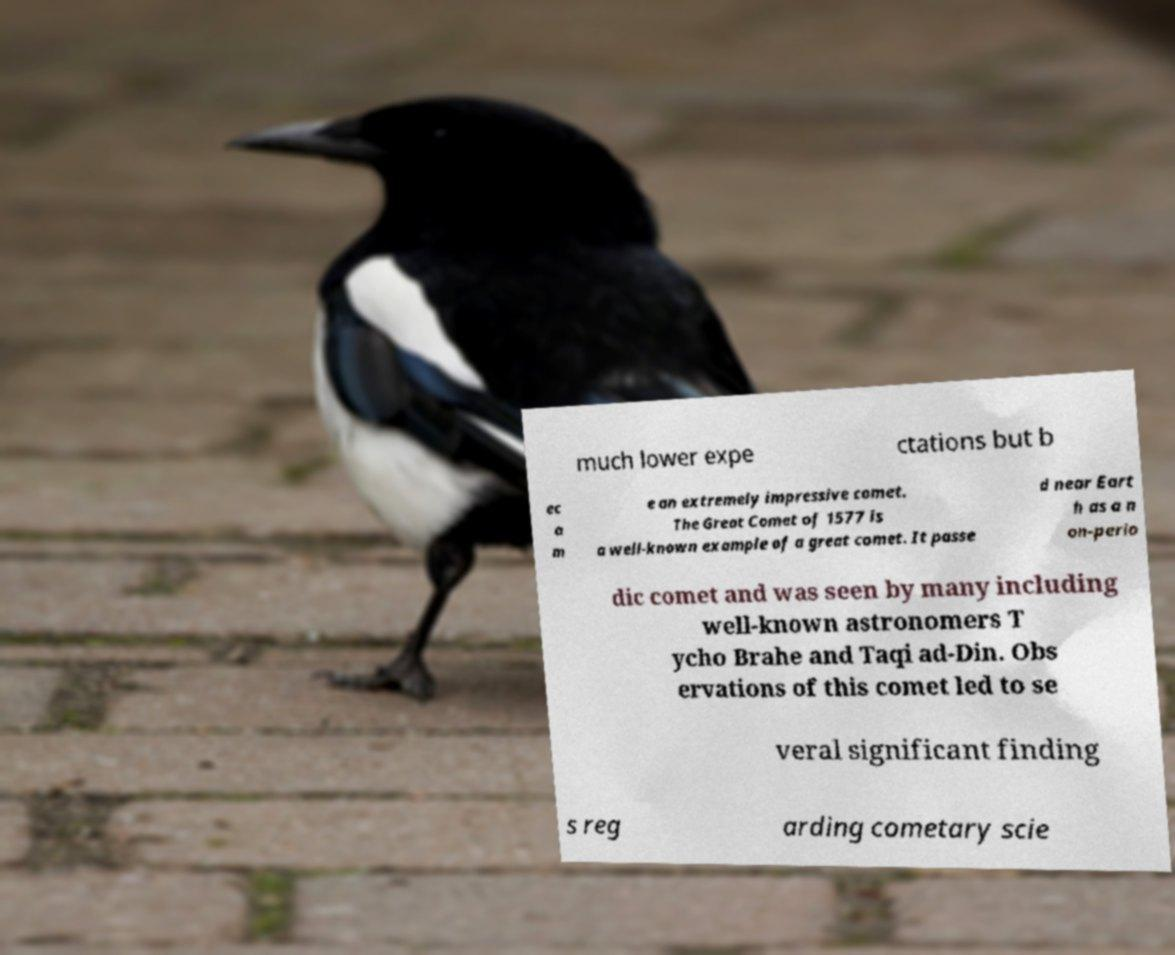Please identify and transcribe the text found in this image. much lower expe ctations but b ec a m e an extremely impressive comet. The Great Comet of 1577 is a well-known example of a great comet. It passe d near Eart h as a n on-perio dic comet and was seen by many including well-known astronomers T ycho Brahe and Taqi ad-Din. Obs ervations of this comet led to se veral significant finding s reg arding cometary scie 